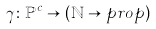Convert formula to latex. <formula><loc_0><loc_0><loc_500><loc_500>& \gamma \colon \mathbb { P } ^ { c } \rightarrow ( \mathbb { N } \rightarrow p r o p )</formula> 